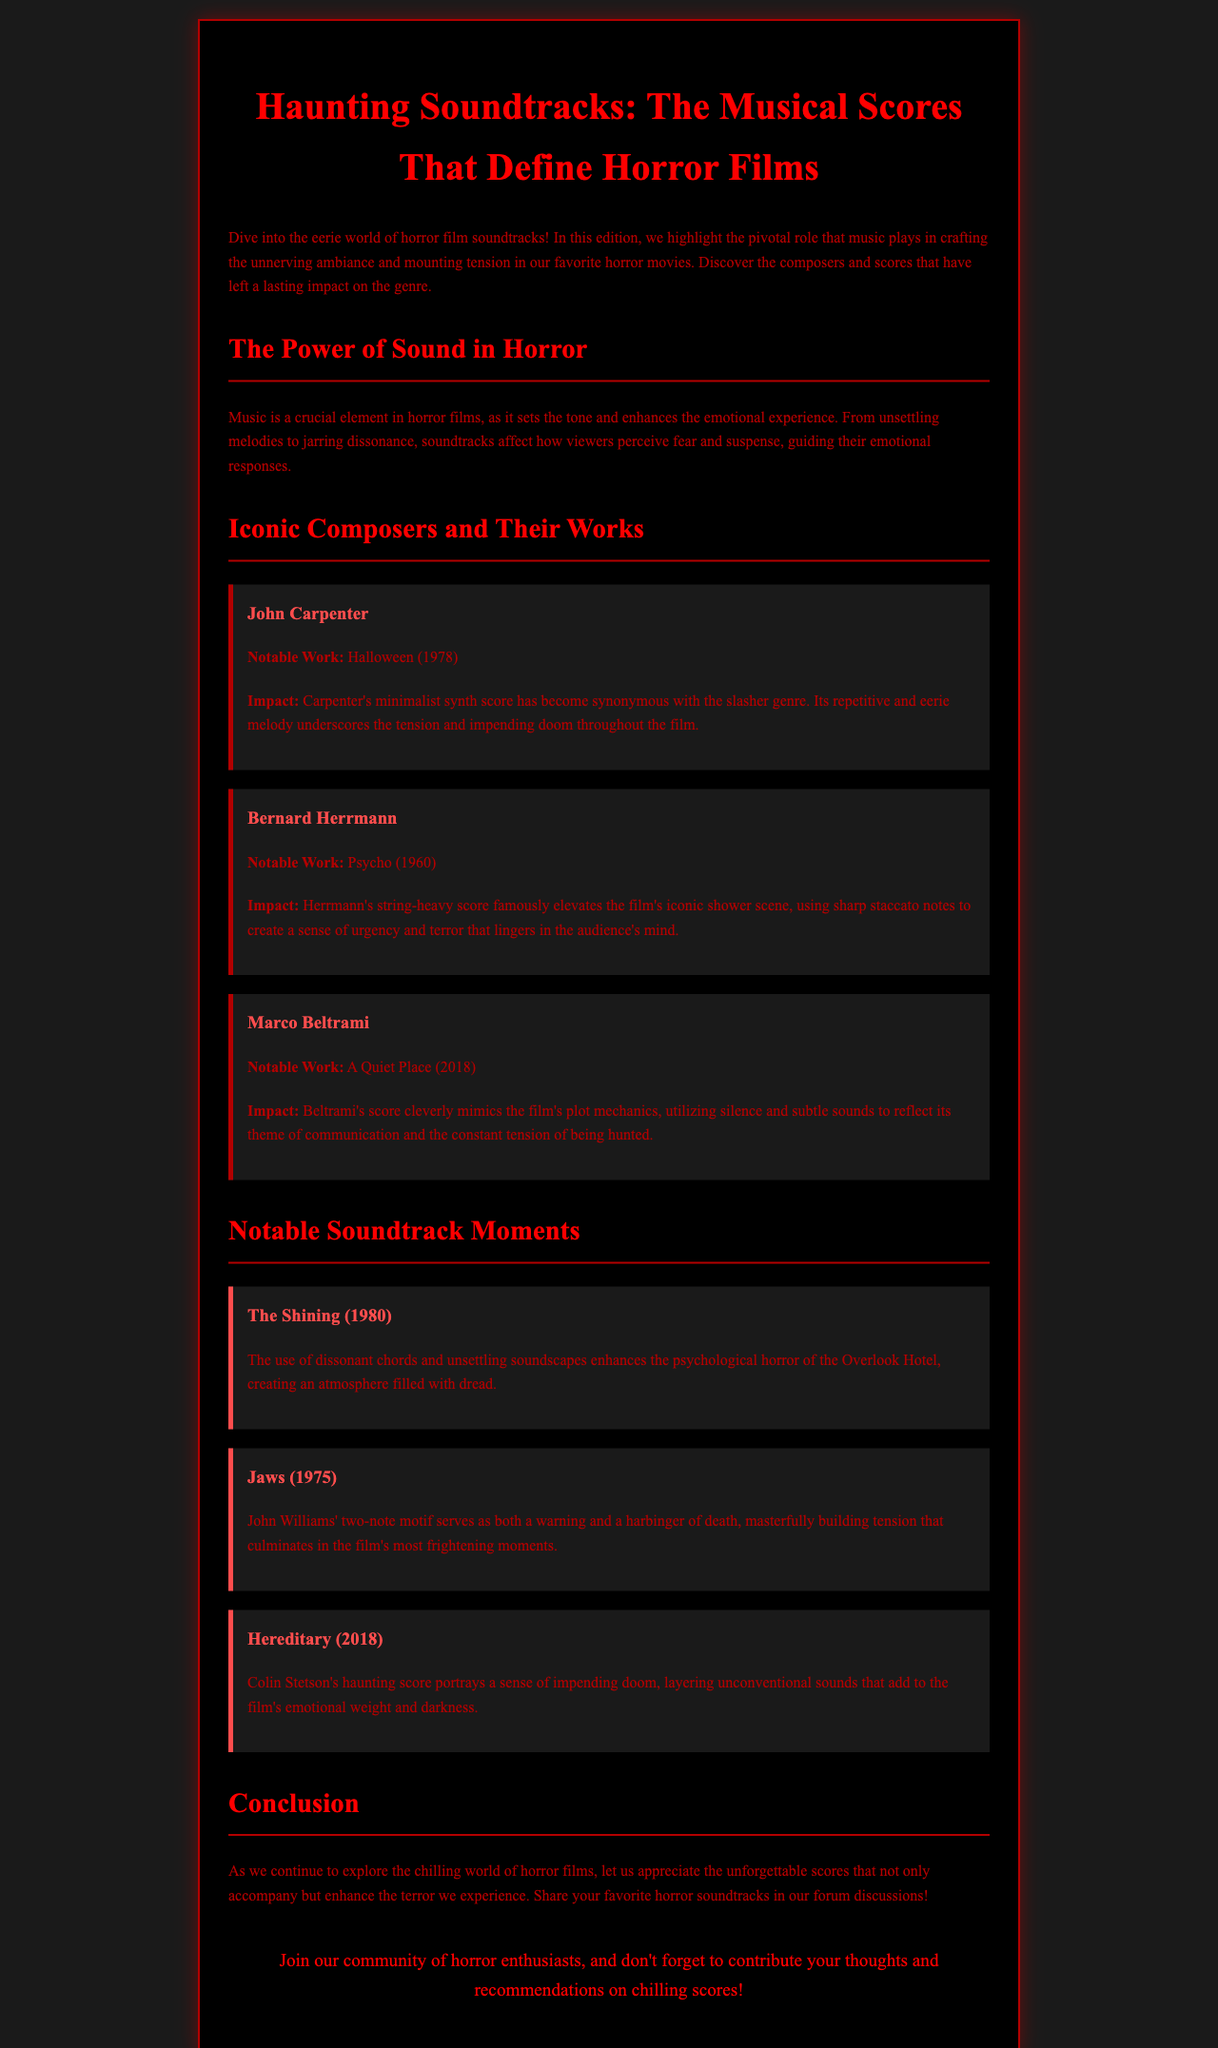what is the title of the newsletter? The title of the newsletter is stated at the top of the document.
Answer: Haunting Soundtracks: The Musical Scores That Define Horror Films who composed the score for Halloween (1978)? The composer associated with the score for Halloween (1978) is mentioned in the specific section for iconic composers.
Answer: John Carpenter what instrument is prominently featured in Herrmann's score for Psycho? The document highlights what type of instruments are used in Bernard Herrmann's score for Psycho.
Answer: Strings which film features a two-note motif by John Williams? The newsletter specifies the film that includes John Williams' two-note motif in its notable soundtrack moments.
Answer: Jaws what year was A Quiet Place released? The release date of A Quiet Place is indicated next to its notable work in the document.
Answer: 2018 what emotion do the soundtracks aim to enhance in horror films? The document discusses the overall emotional experience that soundtracks contribute to in horror films.
Answer: Fear which film's score includes unconventional sounds by Colin Stetson? The film that utilizes unconventional sounds in its score by Colin Stetson is mentioned in the notable soundtrack moments.
Answer: Hereditary what is the primary effect of Carpenter's score in Halloween? The impact of Carpenter's score is outlined in relation to its role in the horror genre.
Answer: Tension and impending doom which film is associated with the term 'psychological horror' in the document? The document refers to a specific film that exemplifies psychological horror through its soundtrack.
Answer: The Shining 